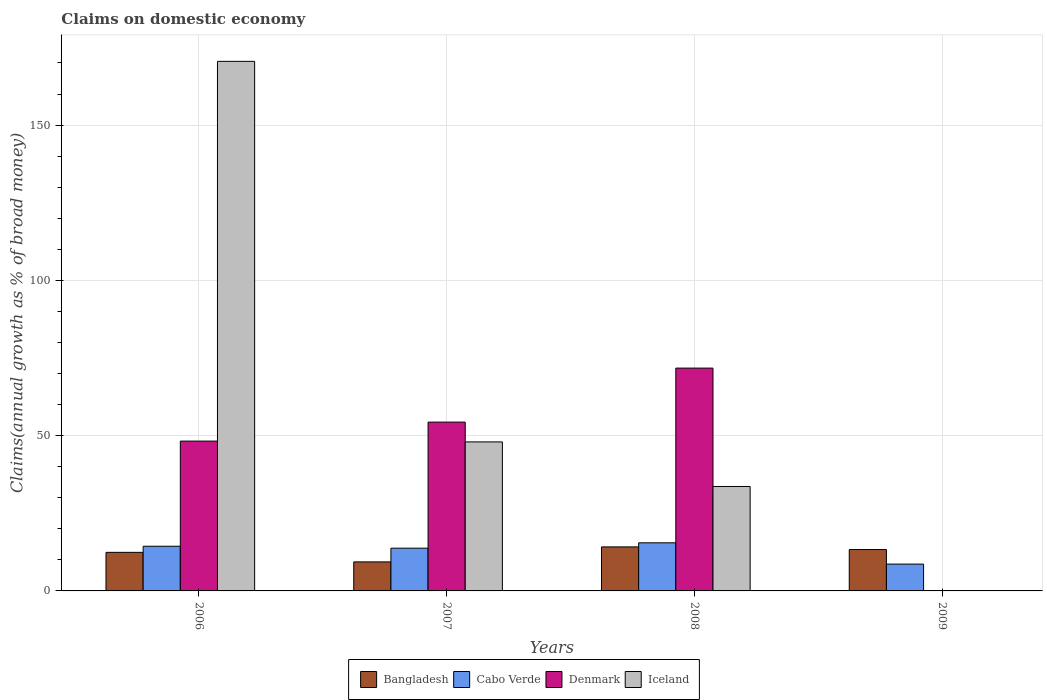How many groups of bars are there?
Provide a succinct answer. 4. Are the number of bars per tick equal to the number of legend labels?
Offer a very short reply. No. How many bars are there on the 1st tick from the left?
Offer a very short reply. 4. What is the label of the 1st group of bars from the left?
Your response must be concise. 2006. What is the percentage of broad money claimed on domestic economy in Denmark in 2007?
Keep it short and to the point. 54.36. Across all years, what is the maximum percentage of broad money claimed on domestic economy in Bangladesh?
Give a very brief answer. 14.17. What is the total percentage of broad money claimed on domestic economy in Cabo Verde in the graph?
Your answer should be very brief. 52.28. What is the difference between the percentage of broad money claimed on domestic economy in Bangladesh in 2006 and that in 2009?
Your answer should be compact. -0.9. What is the difference between the percentage of broad money claimed on domestic economy in Bangladesh in 2008 and the percentage of broad money claimed on domestic economy in Iceland in 2009?
Make the answer very short. 14.17. What is the average percentage of broad money claimed on domestic economy in Bangladesh per year?
Offer a very short reply. 12.31. In the year 2007, what is the difference between the percentage of broad money claimed on domestic economy in Denmark and percentage of broad money claimed on domestic economy in Bangladesh?
Keep it short and to the point. 45.01. In how many years, is the percentage of broad money claimed on domestic economy in Bangladesh greater than 120 %?
Ensure brevity in your answer.  0. What is the ratio of the percentage of broad money claimed on domestic economy in Denmark in 2007 to that in 2008?
Offer a very short reply. 0.76. What is the difference between the highest and the second highest percentage of broad money claimed on domestic economy in Denmark?
Your response must be concise. 17.39. What is the difference between the highest and the lowest percentage of broad money claimed on domestic economy in Bangladesh?
Provide a short and direct response. 4.83. How many bars are there?
Your answer should be compact. 14. How many years are there in the graph?
Ensure brevity in your answer.  4. What is the difference between two consecutive major ticks on the Y-axis?
Your answer should be very brief. 50. Are the values on the major ticks of Y-axis written in scientific E-notation?
Your answer should be very brief. No. Does the graph contain any zero values?
Offer a very short reply. Yes. Does the graph contain grids?
Offer a terse response. Yes. How many legend labels are there?
Ensure brevity in your answer.  4. How are the legend labels stacked?
Give a very brief answer. Horizontal. What is the title of the graph?
Offer a very short reply. Claims on domestic economy. Does "European Union" appear as one of the legend labels in the graph?
Your response must be concise. No. What is the label or title of the X-axis?
Provide a succinct answer. Years. What is the label or title of the Y-axis?
Ensure brevity in your answer.  Claims(annual growth as % of broad money). What is the Claims(annual growth as % of broad money) in Bangladesh in 2006?
Your answer should be very brief. 12.42. What is the Claims(annual growth as % of broad money) of Cabo Verde in 2006?
Your answer should be compact. 14.39. What is the Claims(annual growth as % of broad money) of Denmark in 2006?
Your response must be concise. 48.24. What is the Claims(annual growth as % of broad money) of Iceland in 2006?
Your answer should be compact. 170.52. What is the Claims(annual growth as % of broad money) of Bangladesh in 2007?
Provide a succinct answer. 9.34. What is the Claims(annual growth as % of broad money) of Cabo Verde in 2007?
Your answer should be very brief. 13.76. What is the Claims(annual growth as % of broad money) in Denmark in 2007?
Your answer should be compact. 54.36. What is the Claims(annual growth as % of broad money) in Iceland in 2007?
Keep it short and to the point. 47.98. What is the Claims(annual growth as % of broad money) in Bangladesh in 2008?
Give a very brief answer. 14.17. What is the Claims(annual growth as % of broad money) in Cabo Verde in 2008?
Give a very brief answer. 15.49. What is the Claims(annual growth as % of broad money) of Denmark in 2008?
Provide a succinct answer. 71.75. What is the Claims(annual growth as % of broad money) in Iceland in 2008?
Give a very brief answer. 33.63. What is the Claims(annual growth as % of broad money) of Bangladesh in 2009?
Make the answer very short. 13.32. What is the Claims(annual growth as % of broad money) in Cabo Verde in 2009?
Keep it short and to the point. 8.64. What is the Claims(annual growth as % of broad money) of Denmark in 2009?
Ensure brevity in your answer.  0. Across all years, what is the maximum Claims(annual growth as % of broad money) in Bangladesh?
Offer a terse response. 14.17. Across all years, what is the maximum Claims(annual growth as % of broad money) of Cabo Verde?
Your answer should be compact. 15.49. Across all years, what is the maximum Claims(annual growth as % of broad money) in Denmark?
Your answer should be very brief. 71.75. Across all years, what is the maximum Claims(annual growth as % of broad money) in Iceland?
Provide a short and direct response. 170.52. Across all years, what is the minimum Claims(annual growth as % of broad money) of Bangladesh?
Provide a short and direct response. 9.34. Across all years, what is the minimum Claims(annual growth as % of broad money) in Cabo Verde?
Offer a terse response. 8.64. Across all years, what is the minimum Claims(annual growth as % of broad money) in Denmark?
Provide a short and direct response. 0. Across all years, what is the minimum Claims(annual growth as % of broad money) in Iceland?
Your response must be concise. 0. What is the total Claims(annual growth as % of broad money) of Bangladesh in the graph?
Provide a succinct answer. 49.26. What is the total Claims(annual growth as % of broad money) of Cabo Verde in the graph?
Your response must be concise. 52.28. What is the total Claims(annual growth as % of broad money) in Denmark in the graph?
Offer a very short reply. 174.35. What is the total Claims(annual growth as % of broad money) of Iceland in the graph?
Your answer should be very brief. 252.13. What is the difference between the Claims(annual growth as % of broad money) of Bangladesh in 2006 and that in 2007?
Provide a short and direct response. 3.07. What is the difference between the Claims(annual growth as % of broad money) in Cabo Verde in 2006 and that in 2007?
Your response must be concise. 0.62. What is the difference between the Claims(annual growth as % of broad money) of Denmark in 2006 and that in 2007?
Provide a short and direct response. -6.11. What is the difference between the Claims(annual growth as % of broad money) of Iceland in 2006 and that in 2007?
Offer a very short reply. 122.54. What is the difference between the Claims(annual growth as % of broad money) of Bangladesh in 2006 and that in 2008?
Offer a very short reply. -1.75. What is the difference between the Claims(annual growth as % of broad money) of Cabo Verde in 2006 and that in 2008?
Your answer should be very brief. -1.1. What is the difference between the Claims(annual growth as % of broad money) in Denmark in 2006 and that in 2008?
Your answer should be very brief. -23.5. What is the difference between the Claims(annual growth as % of broad money) in Iceland in 2006 and that in 2008?
Provide a short and direct response. 136.89. What is the difference between the Claims(annual growth as % of broad money) in Bangladesh in 2006 and that in 2009?
Keep it short and to the point. -0.9. What is the difference between the Claims(annual growth as % of broad money) in Cabo Verde in 2006 and that in 2009?
Offer a very short reply. 5.75. What is the difference between the Claims(annual growth as % of broad money) of Bangladesh in 2007 and that in 2008?
Make the answer very short. -4.83. What is the difference between the Claims(annual growth as % of broad money) in Cabo Verde in 2007 and that in 2008?
Your response must be concise. -1.72. What is the difference between the Claims(annual growth as % of broad money) of Denmark in 2007 and that in 2008?
Offer a very short reply. -17.39. What is the difference between the Claims(annual growth as % of broad money) of Iceland in 2007 and that in 2008?
Your answer should be compact. 14.35. What is the difference between the Claims(annual growth as % of broad money) in Bangladesh in 2007 and that in 2009?
Make the answer very short. -3.98. What is the difference between the Claims(annual growth as % of broad money) of Cabo Verde in 2007 and that in 2009?
Your answer should be very brief. 5.12. What is the difference between the Claims(annual growth as % of broad money) of Bangladesh in 2008 and that in 2009?
Give a very brief answer. 0.85. What is the difference between the Claims(annual growth as % of broad money) of Cabo Verde in 2008 and that in 2009?
Provide a short and direct response. 6.85. What is the difference between the Claims(annual growth as % of broad money) in Bangladesh in 2006 and the Claims(annual growth as % of broad money) in Cabo Verde in 2007?
Make the answer very short. -1.34. What is the difference between the Claims(annual growth as % of broad money) in Bangladesh in 2006 and the Claims(annual growth as % of broad money) in Denmark in 2007?
Make the answer very short. -41.94. What is the difference between the Claims(annual growth as % of broad money) in Bangladesh in 2006 and the Claims(annual growth as % of broad money) in Iceland in 2007?
Keep it short and to the point. -35.56. What is the difference between the Claims(annual growth as % of broad money) in Cabo Verde in 2006 and the Claims(annual growth as % of broad money) in Denmark in 2007?
Give a very brief answer. -39.97. What is the difference between the Claims(annual growth as % of broad money) in Cabo Verde in 2006 and the Claims(annual growth as % of broad money) in Iceland in 2007?
Your answer should be very brief. -33.59. What is the difference between the Claims(annual growth as % of broad money) in Denmark in 2006 and the Claims(annual growth as % of broad money) in Iceland in 2007?
Ensure brevity in your answer.  0.26. What is the difference between the Claims(annual growth as % of broad money) of Bangladesh in 2006 and the Claims(annual growth as % of broad money) of Cabo Verde in 2008?
Make the answer very short. -3.07. What is the difference between the Claims(annual growth as % of broad money) in Bangladesh in 2006 and the Claims(annual growth as % of broad money) in Denmark in 2008?
Keep it short and to the point. -59.33. What is the difference between the Claims(annual growth as % of broad money) of Bangladesh in 2006 and the Claims(annual growth as % of broad money) of Iceland in 2008?
Make the answer very short. -21.21. What is the difference between the Claims(annual growth as % of broad money) in Cabo Verde in 2006 and the Claims(annual growth as % of broad money) in Denmark in 2008?
Provide a short and direct response. -57.36. What is the difference between the Claims(annual growth as % of broad money) in Cabo Verde in 2006 and the Claims(annual growth as % of broad money) in Iceland in 2008?
Ensure brevity in your answer.  -19.25. What is the difference between the Claims(annual growth as % of broad money) of Denmark in 2006 and the Claims(annual growth as % of broad money) of Iceland in 2008?
Offer a terse response. 14.61. What is the difference between the Claims(annual growth as % of broad money) of Bangladesh in 2006 and the Claims(annual growth as % of broad money) of Cabo Verde in 2009?
Your answer should be compact. 3.78. What is the difference between the Claims(annual growth as % of broad money) of Bangladesh in 2007 and the Claims(annual growth as % of broad money) of Cabo Verde in 2008?
Ensure brevity in your answer.  -6.14. What is the difference between the Claims(annual growth as % of broad money) in Bangladesh in 2007 and the Claims(annual growth as % of broad money) in Denmark in 2008?
Your response must be concise. -62.4. What is the difference between the Claims(annual growth as % of broad money) of Bangladesh in 2007 and the Claims(annual growth as % of broad money) of Iceland in 2008?
Your answer should be very brief. -24.29. What is the difference between the Claims(annual growth as % of broad money) in Cabo Verde in 2007 and the Claims(annual growth as % of broad money) in Denmark in 2008?
Ensure brevity in your answer.  -57.98. What is the difference between the Claims(annual growth as % of broad money) of Cabo Verde in 2007 and the Claims(annual growth as % of broad money) of Iceland in 2008?
Keep it short and to the point. -19.87. What is the difference between the Claims(annual growth as % of broad money) of Denmark in 2007 and the Claims(annual growth as % of broad money) of Iceland in 2008?
Your response must be concise. 20.72. What is the difference between the Claims(annual growth as % of broad money) of Bangladesh in 2007 and the Claims(annual growth as % of broad money) of Cabo Verde in 2009?
Ensure brevity in your answer.  0.71. What is the difference between the Claims(annual growth as % of broad money) in Bangladesh in 2008 and the Claims(annual growth as % of broad money) in Cabo Verde in 2009?
Your answer should be compact. 5.54. What is the average Claims(annual growth as % of broad money) in Bangladesh per year?
Provide a succinct answer. 12.31. What is the average Claims(annual growth as % of broad money) of Cabo Verde per year?
Provide a succinct answer. 13.07. What is the average Claims(annual growth as % of broad money) in Denmark per year?
Offer a terse response. 43.59. What is the average Claims(annual growth as % of broad money) of Iceland per year?
Offer a very short reply. 63.03. In the year 2006, what is the difference between the Claims(annual growth as % of broad money) of Bangladesh and Claims(annual growth as % of broad money) of Cabo Verde?
Ensure brevity in your answer.  -1.97. In the year 2006, what is the difference between the Claims(annual growth as % of broad money) of Bangladesh and Claims(annual growth as % of broad money) of Denmark?
Provide a succinct answer. -35.82. In the year 2006, what is the difference between the Claims(annual growth as % of broad money) in Bangladesh and Claims(annual growth as % of broad money) in Iceland?
Keep it short and to the point. -158.1. In the year 2006, what is the difference between the Claims(annual growth as % of broad money) of Cabo Verde and Claims(annual growth as % of broad money) of Denmark?
Offer a very short reply. -33.86. In the year 2006, what is the difference between the Claims(annual growth as % of broad money) of Cabo Verde and Claims(annual growth as % of broad money) of Iceland?
Provide a succinct answer. -156.13. In the year 2006, what is the difference between the Claims(annual growth as % of broad money) of Denmark and Claims(annual growth as % of broad money) of Iceland?
Provide a short and direct response. -122.28. In the year 2007, what is the difference between the Claims(annual growth as % of broad money) of Bangladesh and Claims(annual growth as % of broad money) of Cabo Verde?
Offer a terse response. -4.42. In the year 2007, what is the difference between the Claims(annual growth as % of broad money) of Bangladesh and Claims(annual growth as % of broad money) of Denmark?
Provide a succinct answer. -45.01. In the year 2007, what is the difference between the Claims(annual growth as % of broad money) of Bangladesh and Claims(annual growth as % of broad money) of Iceland?
Your answer should be very brief. -38.64. In the year 2007, what is the difference between the Claims(annual growth as % of broad money) in Cabo Verde and Claims(annual growth as % of broad money) in Denmark?
Offer a very short reply. -40.59. In the year 2007, what is the difference between the Claims(annual growth as % of broad money) in Cabo Verde and Claims(annual growth as % of broad money) in Iceland?
Your answer should be compact. -34.22. In the year 2007, what is the difference between the Claims(annual growth as % of broad money) in Denmark and Claims(annual growth as % of broad money) in Iceland?
Your answer should be compact. 6.38. In the year 2008, what is the difference between the Claims(annual growth as % of broad money) of Bangladesh and Claims(annual growth as % of broad money) of Cabo Verde?
Keep it short and to the point. -1.31. In the year 2008, what is the difference between the Claims(annual growth as % of broad money) of Bangladesh and Claims(annual growth as % of broad money) of Denmark?
Provide a short and direct response. -57.57. In the year 2008, what is the difference between the Claims(annual growth as % of broad money) of Bangladesh and Claims(annual growth as % of broad money) of Iceland?
Keep it short and to the point. -19.46. In the year 2008, what is the difference between the Claims(annual growth as % of broad money) in Cabo Verde and Claims(annual growth as % of broad money) in Denmark?
Provide a short and direct response. -56.26. In the year 2008, what is the difference between the Claims(annual growth as % of broad money) of Cabo Verde and Claims(annual growth as % of broad money) of Iceland?
Give a very brief answer. -18.15. In the year 2008, what is the difference between the Claims(annual growth as % of broad money) of Denmark and Claims(annual growth as % of broad money) of Iceland?
Provide a succinct answer. 38.11. In the year 2009, what is the difference between the Claims(annual growth as % of broad money) of Bangladesh and Claims(annual growth as % of broad money) of Cabo Verde?
Your answer should be very brief. 4.68. What is the ratio of the Claims(annual growth as % of broad money) of Bangladesh in 2006 to that in 2007?
Your answer should be compact. 1.33. What is the ratio of the Claims(annual growth as % of broad money) of Cabo Verde in 2006 to that in 2007?
Make the answer very short. 1.05. What is the ratio of the Claims(annual growth as % of broad money) of Denmark in 2006 to that in 2007?
Give a very brief answer. 0.89. What is the ratio of the Claims(annual growth as % of broad money) of Iceland in 2006 to that in 2007?
Offer a very short reply. 3.55. What is the ratio of the Claims(annual growth as % of broad money) in Bangladesh in 2006 to that in 2008?
Give a very brief answer. 0.88. What is the ratio of the Claims(annual growth as % of broad money) of Cabo Verde in 2006 to that in 2008?
Your response must be concise. 0.93. What is the ratio of the Claims(annual growth as % of broad money) in Denmark in 2006 to that in 2008?
Provide a succinct answer. 0.67. What is the ratio of the Claims(annual growth as % of broad money) of Iceland in 2006 to that in 2008?
Give a very brief answer. 5.07. What is the ratio of the Claims(annual growth as % of broad money) in Bangladesh in 2006 to that in 2009?
Your answer should be very brief. 0.93. What is the ratio of the Claims(annual growth as % of broad money) of Cabo Verde in 2006 to that in 2009?
Make the answer very short. 1.67. What is the ratio of the Claims(annual growth as % of broad money) of Bangladesh in 2007 to that in 2008?
Offer a very short reply. 0.66. What is the ratio of the Claims(annual growth as % of broad money) in Cabo Verde in 2007 to that in 2008?
Your answer should be very brief. 0.89. What is the ratio of the Claims(annual growth as % of broad money) in Denmark in 2007 to that in 2008?
Provide a succinct answer. 0.76. What is the ratio of the Claims(annual growth as % of broad money) of Iceland in 2007 to that in 2008?
Your answer should be very brief. 1.43. What is the ratio of the Claims(annual growth as % of broad money) in Bangladesh in 2007 to that in 2009?
Offer a very short reply. 0.7. What is the ratio of the Claims(annual growth as % of broad money) in Cabo Verde in 2007 to that in 2009?
Your answer should be compact. 1.59. What is the ratio of the Claims(annual growth as % of broad money) of Bangladesh in 2008 to that in 2009?
Offer a terse response. 1.06. What is the ratio of the Claims(annual growth as % of broad money) of Cabo Verde in 2008 to that in 2009?
Make the answer very short. 1.79. What is the difference between the highest and the second highest Claims(annual growth as % of broad money) of Bangladesh?
Provide a succinct answer. 0.85. What is the difference between the highest and the second highest Claims(annual growth as % of broad money) in Cabo Verde?
Offer a very short reply. 1.1. What is the difference between the highest and the second highest Claims(annual growth as % of broad money) in Denmark?
Provide a short and direct response. 17.39. What is the difference between the highest and the second highest Claims(annual growth as % of broad money) in Iceland?
Ensure brevity in your answer.  122.54. What is the difference between the highest and the lowest Claims(annual growth as % of broad money) of Bangladesh?
Offer a terse response. 4.83. What is the difference between the highest and the lowest Claims(annual growth as % of broad money) in Cabo Verde?
Your response must be concise. 6.85. What is the difference between the highest and the lowest Claims(annual growth as % of broad money) of Denmark?
Your answer should be compact. 71.75. What is the difference between the highest and the lowest Claims(annual growth as % of broad money) of Iceland?
Make the answer very short. 170.52. 